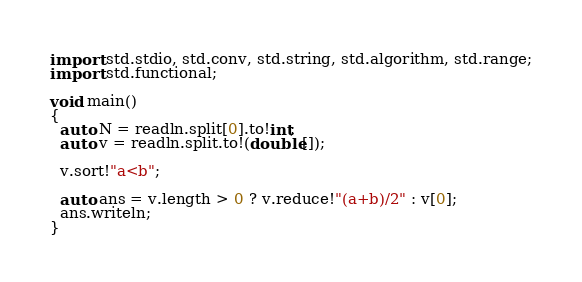<code> <loc_0><loc_0><loc_500><loc_500><_D_>import std.stdio, std.conv, std.string, std.algorithm, std.range;
import std.functional;

void main()
{
  auto N = readln.split[0].to!int;
  auto v = readln.split.to!(double[]);

  v.sort!"a<b";

  auto ans = v.length > 0 ? v.reduce!"(a+b)/2" : v[0];
  ans.writeln;
}
</code> 